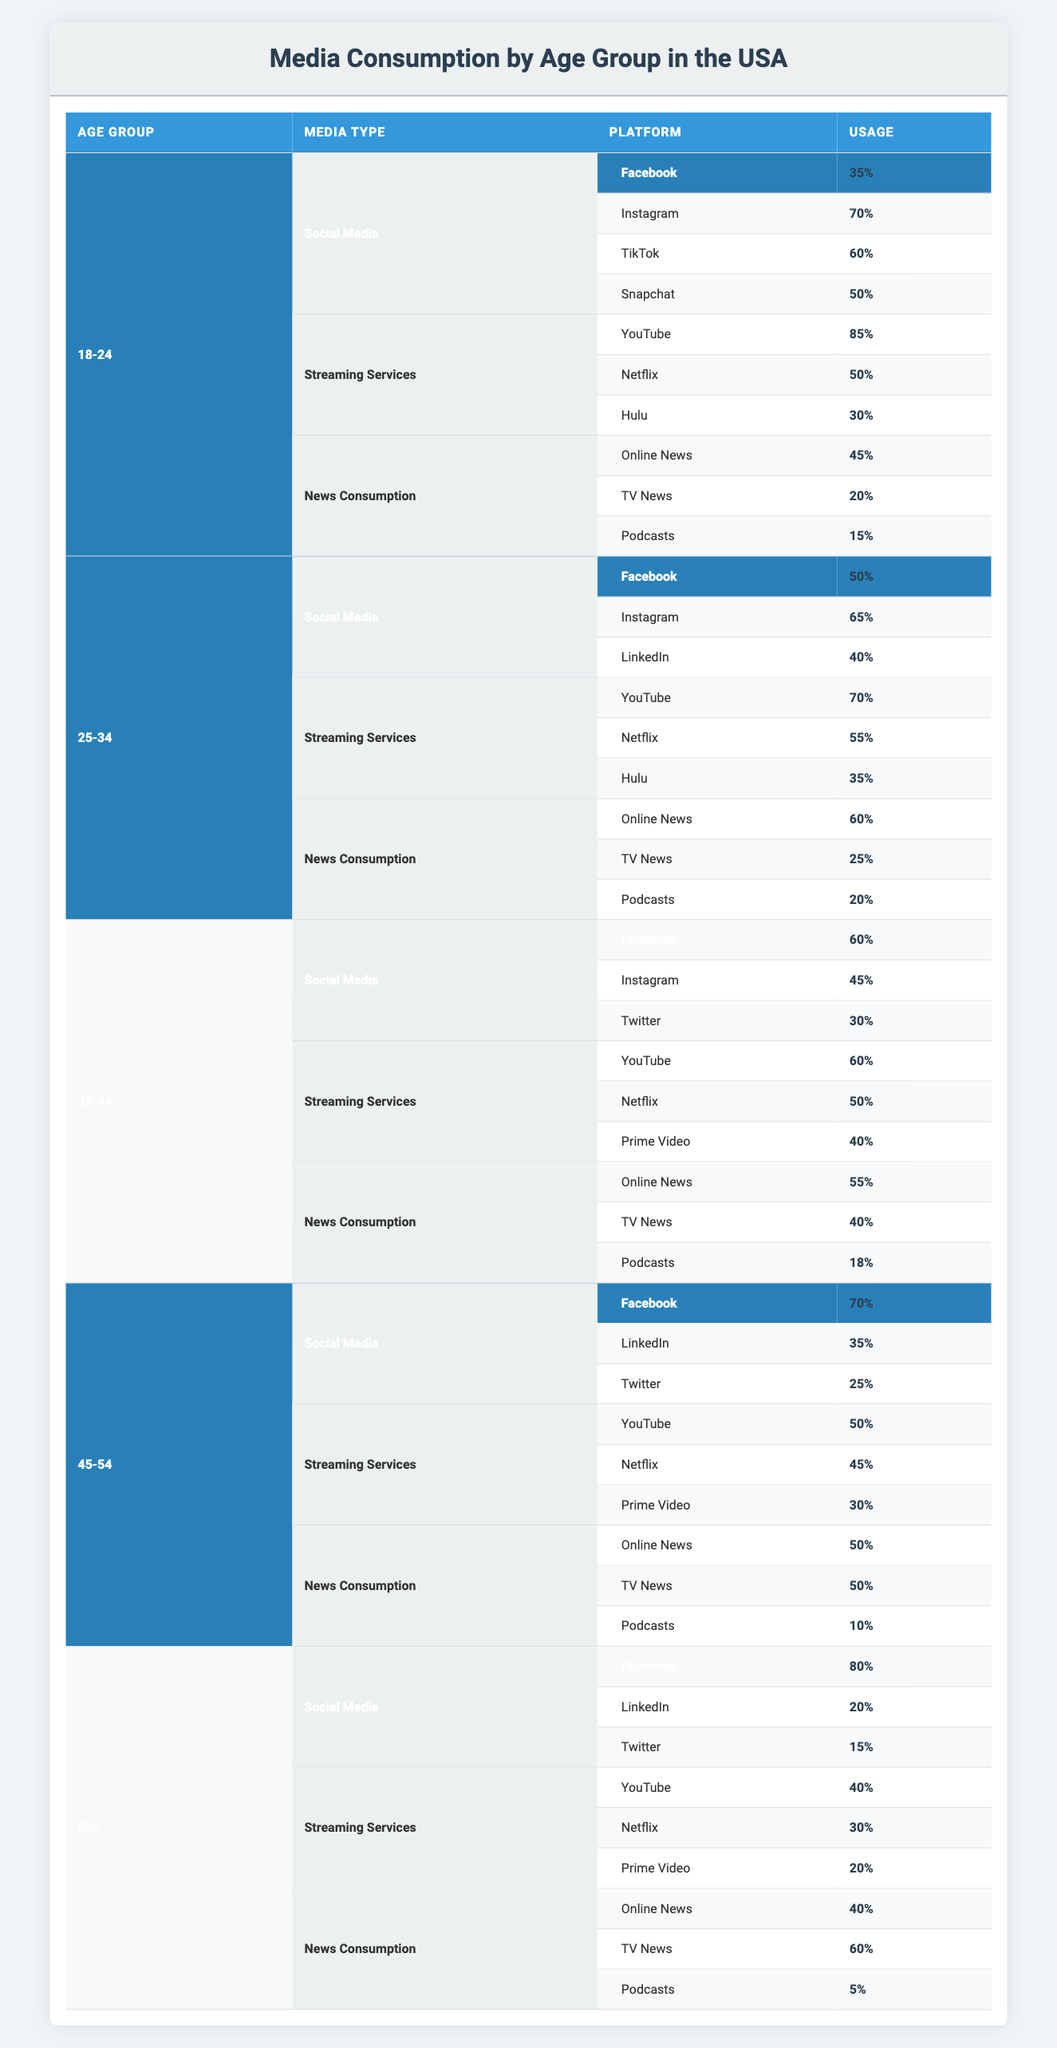What is the percentage of Instagram usage in the 18-24 age group? The table shows that Instagram usage among the 18-24 age group is specifically listed under Social Media, with a value of 70%.
Answer: 70% Which age group has the highest percentage of Facebook usage? Looking at the table, we can see that among all age groups, the 55+ age group has the highest Facebook usage at 80%.
Answer: 80% What is the combined percentage of online news consumption across all age groups? The percentages for online news consumption in each age group are: 45% (18-24) + 60% (25-34) + 55% (35-44) + 50% (45-54) + 40% (55+) = 250%. To find the average, we divide by the number of age groups (5), resulting in 250% / 5 = 50%.
Answer: 50% True or False: The percentage of TikTok users in the 25-34 age group is higher than that of Instagram users in the same age group. The table indicates that TikTok is not listed in the 25-34 group under Social Media; therefore, we can't say it's higher than Instagram, which has 65%. So, the statement is false.
Answer: False Which streaming service has the lowest percentage usage among the 45-54 age group? Under the Streaming Services category for the 45-54 age group, the percentages are: YouTube (50%), Netflix (45%), and Prime Video (30%). Prime Video has the lowest at 30%.
Answer: 30% In the 35-44 age group, what is the total percentage of social media usage if you combine Facebook and Instagram? Referring to the table, Facebook usage is 60% and Instagram usage is 45%. Adding these two values gives 60% + 45% = 105%.
Answer: 105% How much more likely are people aged 18-24 to use YouTube compared to those aged 55+? YouTube usage for 18-24 is 85% and for 55+ is 40%. The difference is 85% - 40% = 45%, meaning people aged 18-24 are 45% more likely to use YouTube.
Answer: 45% What percentage of the 45-54 age group consumes podcasts? The table shows that the 45-54 age group has 10% podcast usage listed under the News Consumption category.
Answer: 10% 